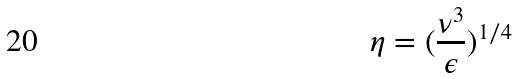<formula> <loc_0><loc_0><loc_500><loc_500>\eta = ( \frac { \nu ^ { 3 } } { \epsilon } ) ^ { 1 / 4 }</formula> 